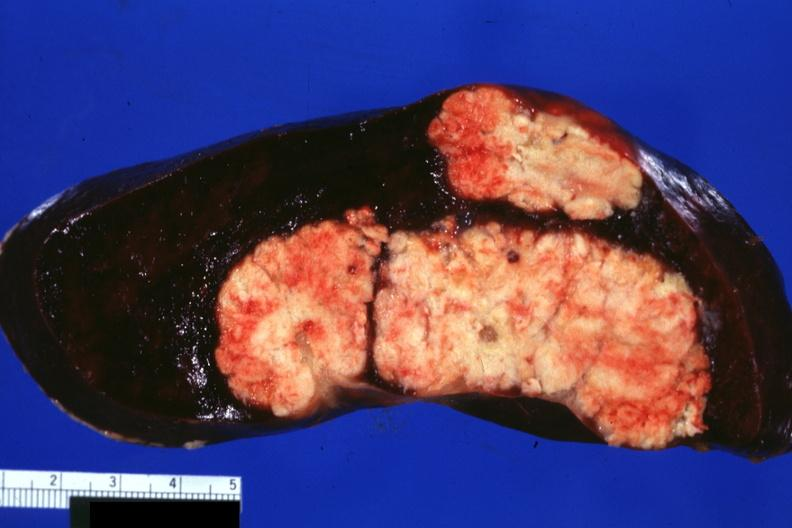does this image show large and very typical metastatic lesions in spleen very well shown?
Answer the question using a single word or phrase. Yes 